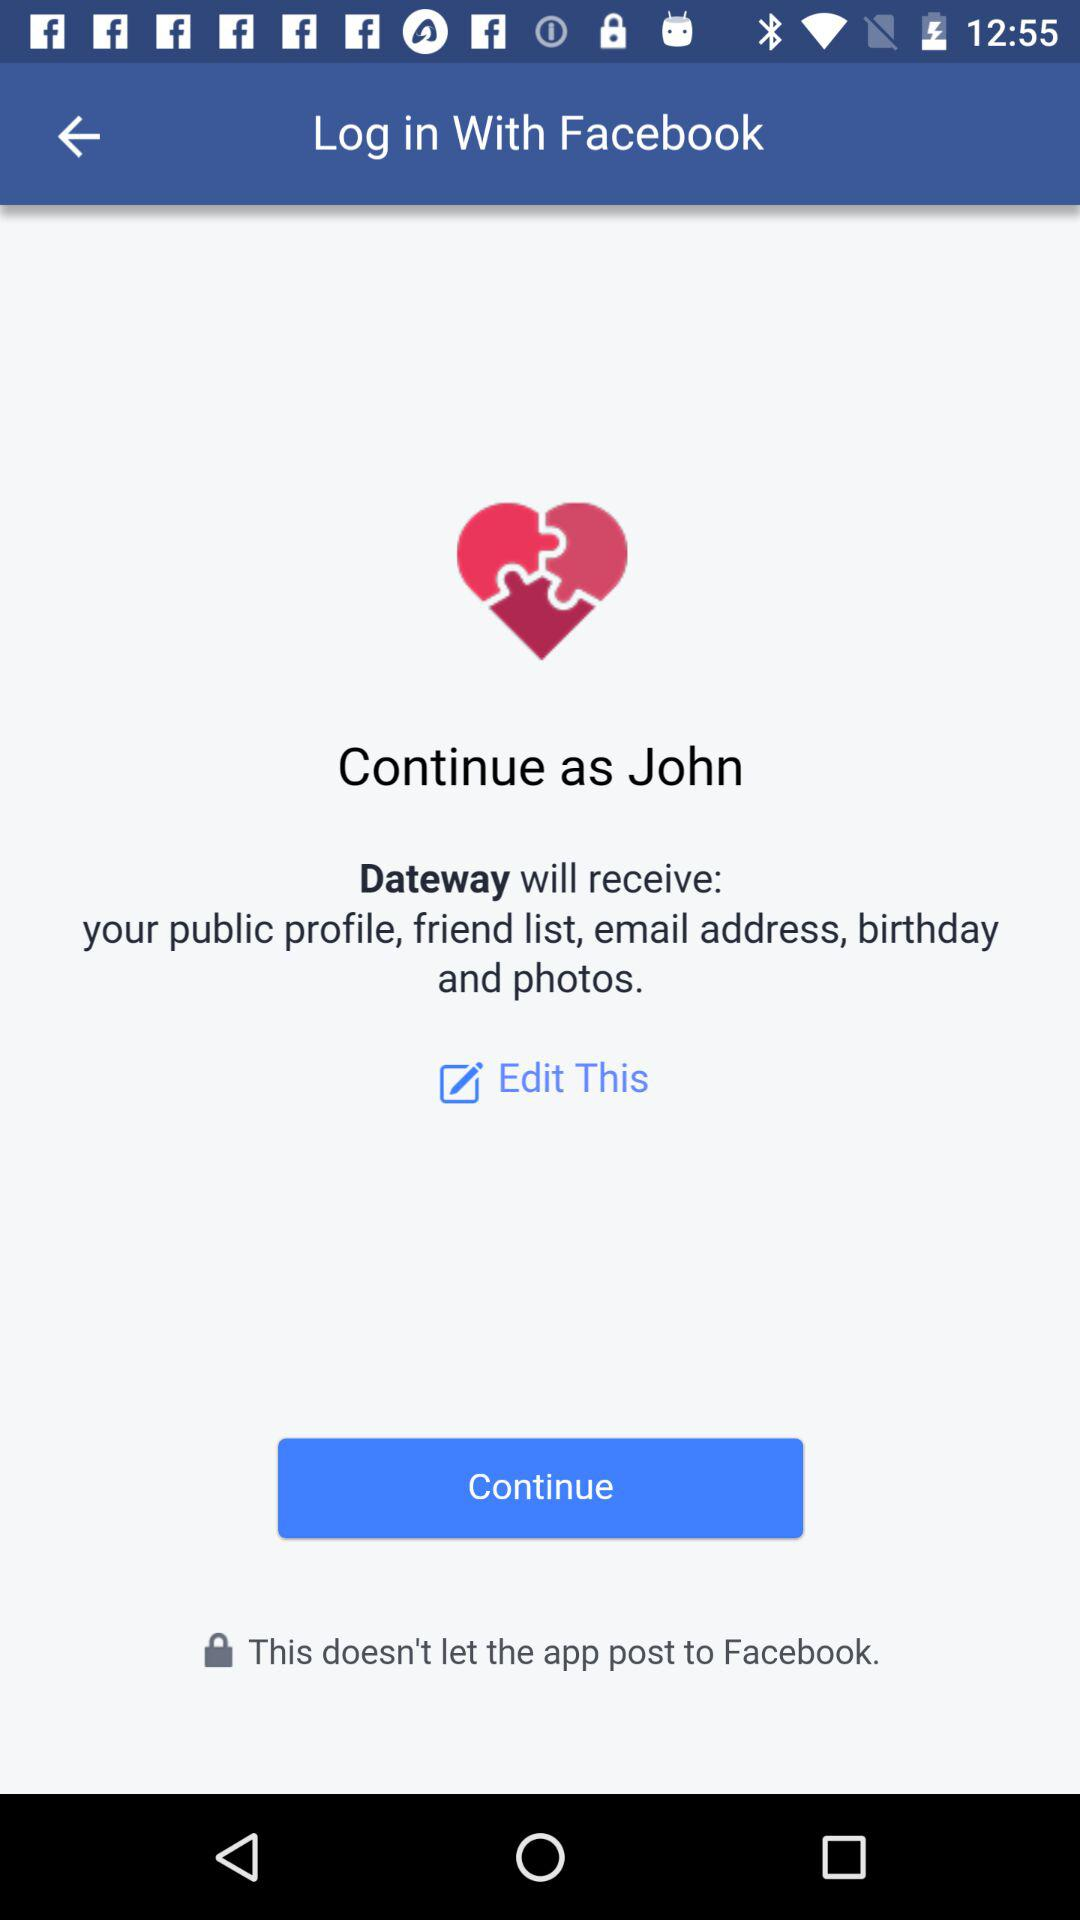What application will receive the public profile, friend list, email address, birthday and photos? The public profile, friend list, email address, birthday and photos will be received by "Dateway". 